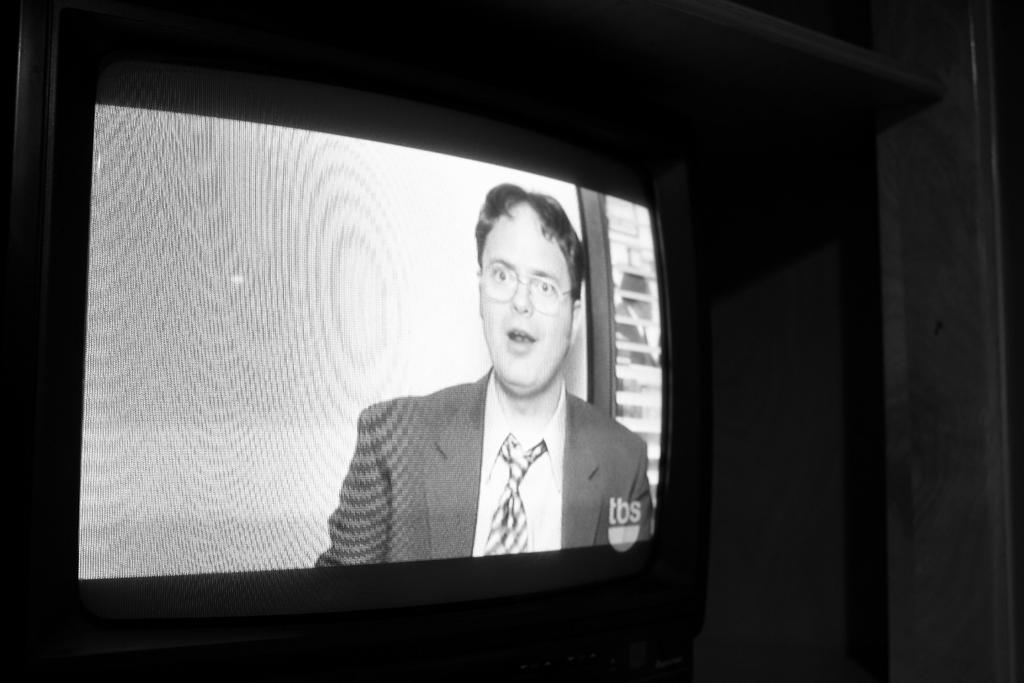What electronic device is visible in the image? There is a display screen of a television in the image. How many dogs are jumping on the robin in the image? There are no dogs or robins present in the image; it only features a display screen of a television. 